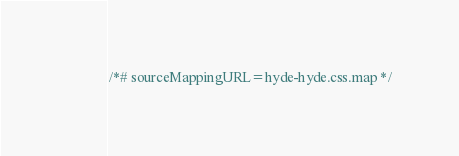<code> <loc_0><loc_0><loc_500><loc_500><_CSS_>
/*# sourceMappingURL=hyde-hyde.css.map */</code> 